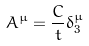<formula> <loc_0><loc_0><loc_500><loc_500>A ^ { \mu } = \frac { C } { t } \delta _ { 3 } ^ { \mu }</formula> 